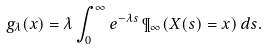Convert formula to latex. <formula><loc_0><loc_0><loc_500><loc_500>g _ { \lambda } ( x ) = \lambda \int _ { 0 } ^ { \infty } e ^ { - \lambda s } \, \P _ { \infty } ( X ( s ) = x ) \, d s .</formula> 